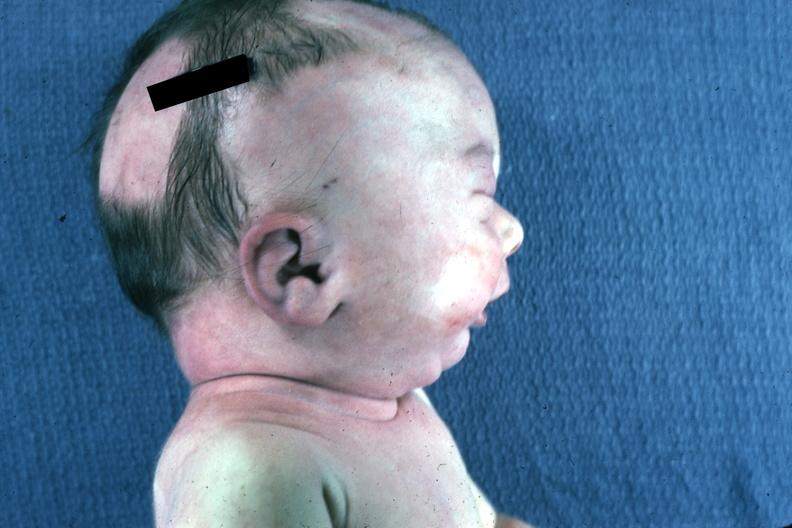s digits present?
Answer the question using a single word or phrase. No 